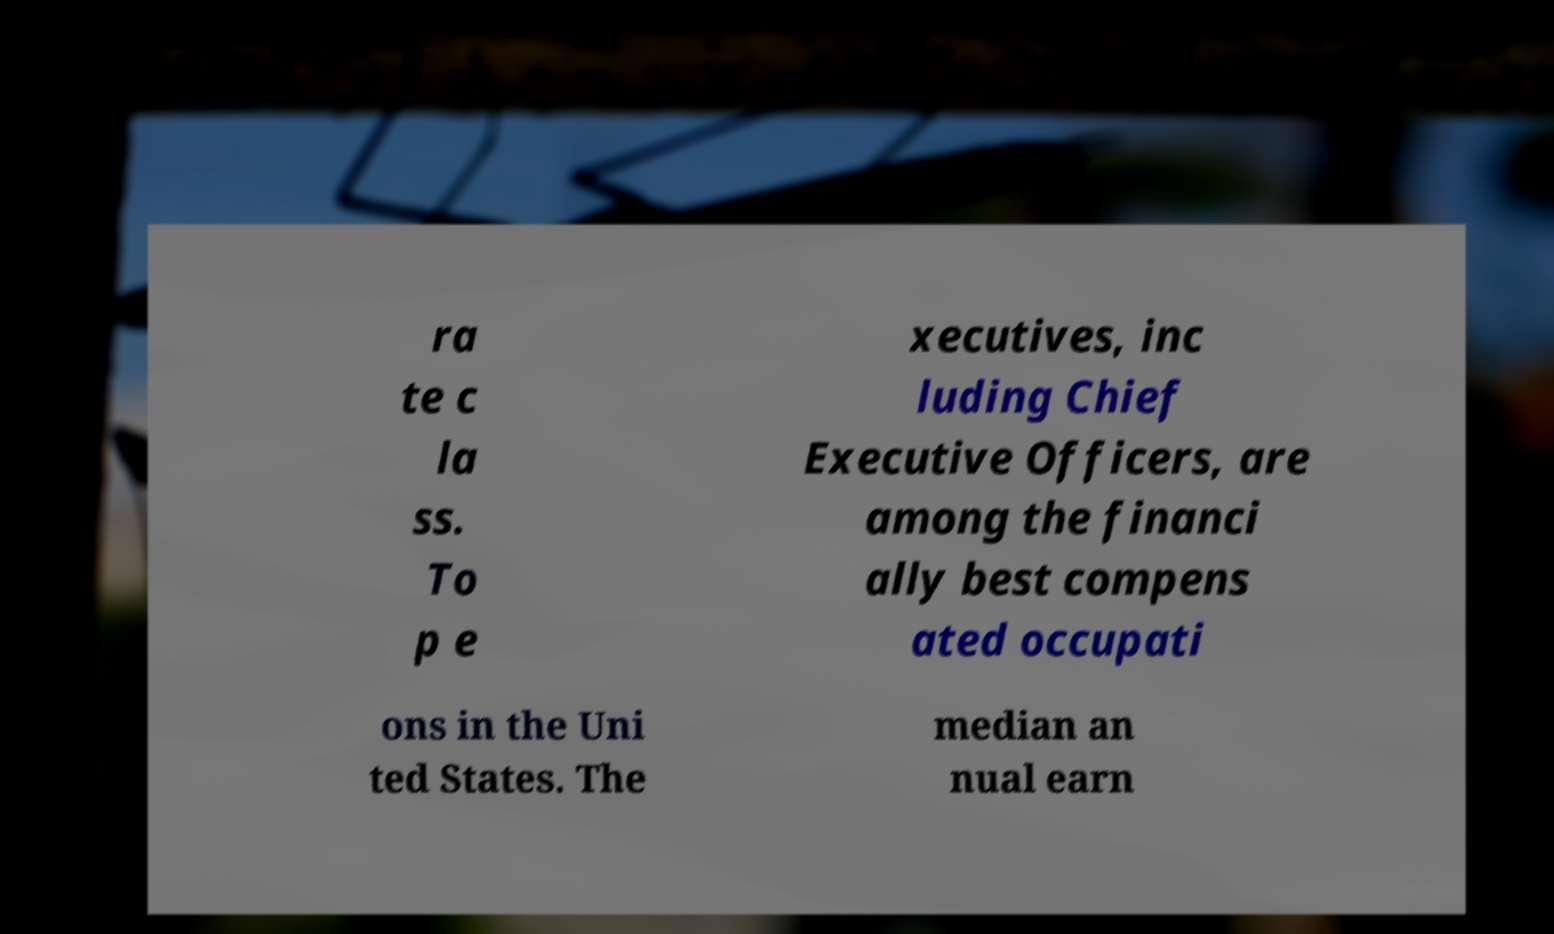Can you accurately transcribe the text from the provided image for me? ra te c la ss. To p e xecutives, inc luding Chief Executive Officers, are among the financi ally best compens ated occupati ons in the Uni ted States. The median an nual earn 